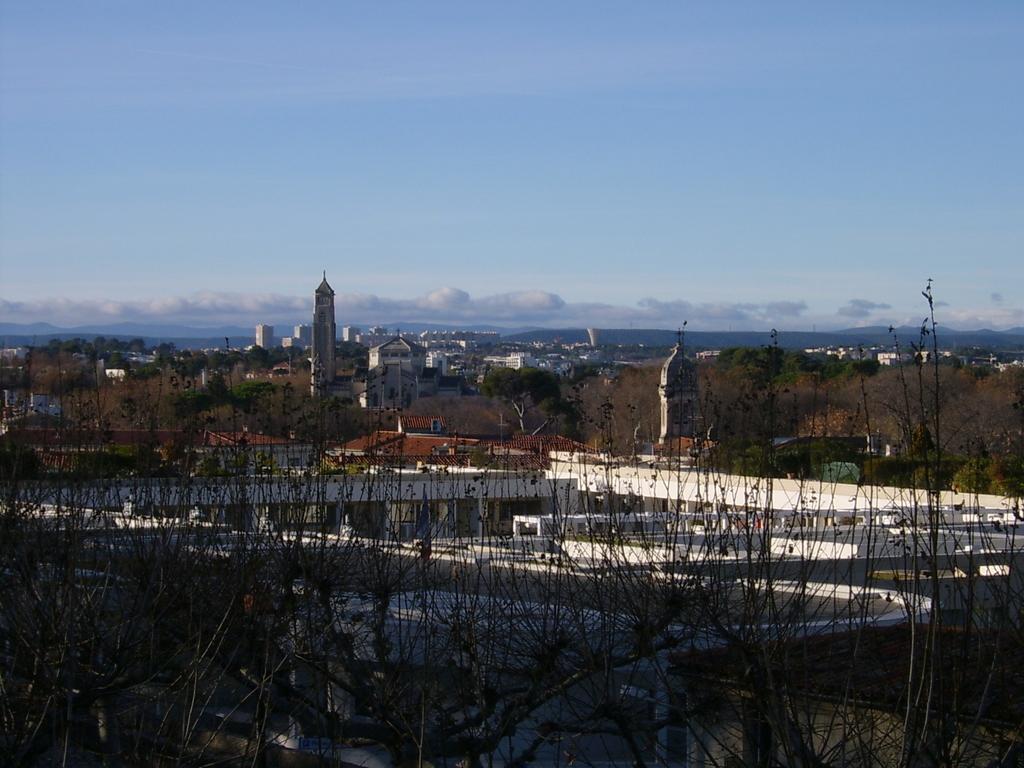Please provide a concise description of this image. In this picture I can see number of trees and buildings in front. In the background I can see the sky, which is a bit cloudy. 